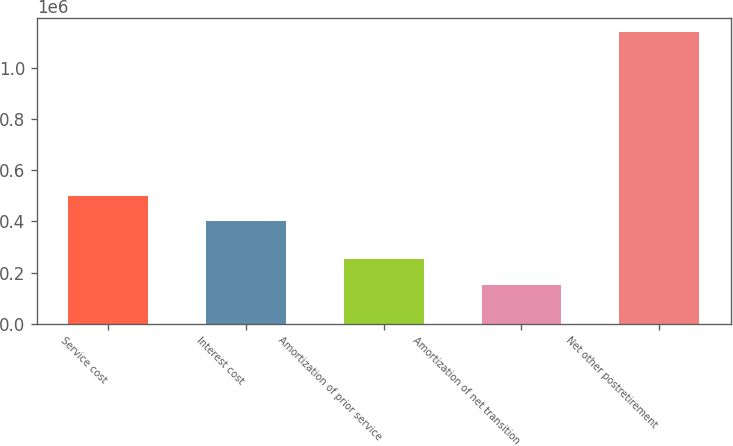<chart> <loc_0><loc_0><loc_500><loc_500><bar_chart><fcel>Service cost<fcel>Interest cost<fcel>Amortization of prior service<fcel>Amortization of net transition<fcel>Net other postretirement<nl><fcel>500600<fcel>402000<fcel>251600<fcel>153000<fcel>1.139e+06<nl></chart> 